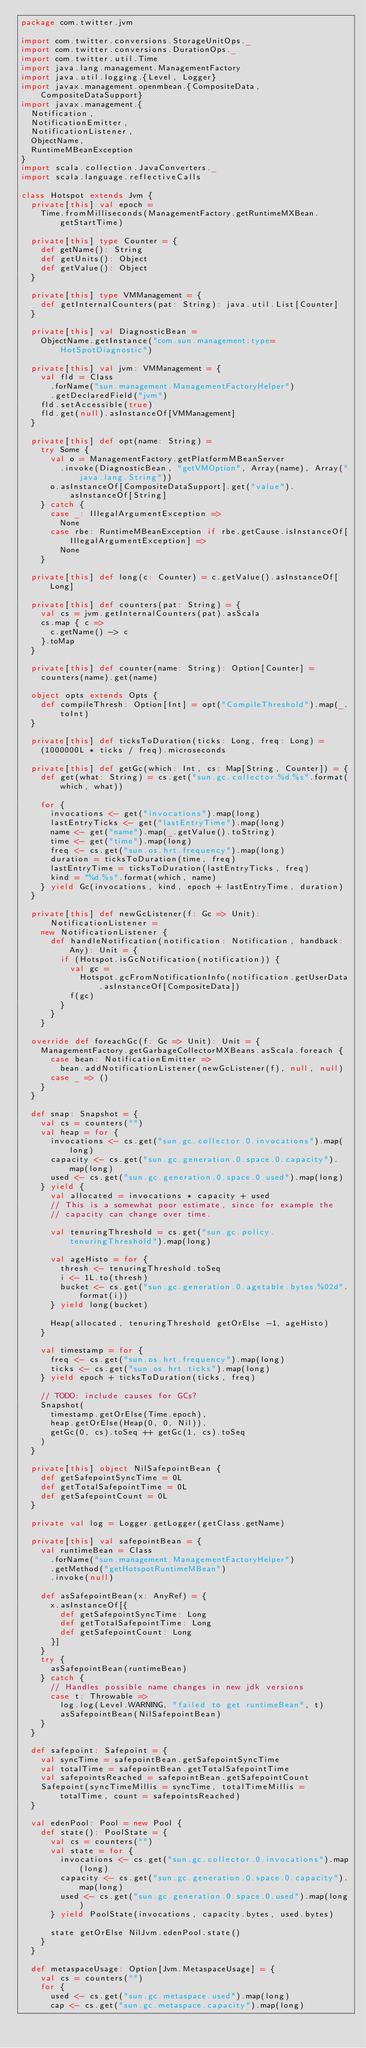<code> <loc_0><loc_0><loc_500><loc_500><_Scala_>package com.twitter.jvm

import com.twitter.conversions.StorageUnitOps._
import com.twitter.conversions.DurationOps._
import com.twitter.util.Time
import java.lang.management.ManagementFactory
import java.util.logging.{Level, Logger}
import javax.management.openmbean.{CompositeData, CompositeDataSupport}
import javax.management.{
  Notification,
  NotificationEmitter,
  NotificationListener,
  ObjectName,
  RuntimeMBeanException
}
import scala.collection.JavaConverters._
import scala.language.reflectiveCalls

class Hotspot extends Jvm {
  private[this] val epoch =
    Time.fromMilliseconds(ManagementFactory.getRuntimeMXBean.getStartTime)

  private[this] type Counter = {
    def getName(): String
    def getUnits(): Object
    def getValue(): Object
  }

  private[this] type VMManagement = {
    def getInternalCounters(pat: String): java.util.List[Counter]
  }

  private[this] val DiagnosticBean =
    ObjectName.getInstance("com.sun.management:type=HotSpotDiagnostic")

  private[this] val jvm: VMManagement = {
    val fld = Class
      .forName("sun.management.ManagementFactoryHelper")
      .getDeclaredField("jvm")
    fld.setAccessible(true)
    fld.get(null).asInstanceOf[VMManagement]
  }

  private[this] def opt(name: String) =
    try Some {
      val o = ManagementFactory.getPlatformMBeanServer
        .invoke(DiagnosticBean, "getVMOption", Array(name), Array("java.lang.String"))
      o.asInstanceOf[CompositeDataSupport].get("value").asInstanceOf[String]
    } catch {
      case _: IllegalArgumentException =>
        None
      case rbe: RuntimeMBeanException if rbe.getCause.isInstanceOf[IllegalArgumentException] =>
        None
    }

  private[this] def long(c: Counter) = c.getValue().asInstanceOf[Long]

  private[this] def counters(pat: String) = {
    val cs = jvm.getInternalCounters(pat).asScala
    cs.map { c =>
      c.getName() -> c
    }.toMap
  }

  private[this] def counter(name: String): Option[Counter] =
    counters(name).get(name)

  object opts extends Opts {
    def compileThresh: Option[Int] = opt("CompileThreshold").map(_.toInt)
  }

  private[this] def ticksToDuration(ticks: Long, freq: Long) =
    (1000000L * ticks / freq).microseconds

  private[this] def getGc(which: Int, cs: Map[String, Counter]) = {
    def get(what: String) = cs.get("sun.gc.collector.%d.%s".format(which, what))

    for {
      invocations <- get("invocations").map(long)
      lastEntryTicks <- get("lastEntryTime").map(long)
      name <- get("name").map(_.getValue().toString)
      time <- get("time").map(long)
      freq <- cs.get("sun.os.hrt.frequency").map(long)
      duration = ticksToDuration(time, freq)
      lastEntryTime = ticksToDuration(lastEntryTicks, freq)
      kind = "%d.%s".format(which, name)
    } yield Gc(invocations, kind, epoch + lastEntryTime, duration)
  }

  private[this] def newGcListener(f: Gc => Unit): NotificationListener =
    new NotificationListener {
      def handleNotification(notification: Notification, handback: Any): Unit = {
        if (Hotspot.isGcNotification(notification)) {
          val gc =
            Hotspot.gcFromNotificationInfo(notification.getUserData.asInstanceOf[CompositeData])
          f(gc)
        }
      }
    }

  override def foreachGc(f: Gc => Unit): Unit = {
    ManagementFactory.getGarbageCollectorMXBeans.asScala.foreach {
      case bean: NotificationEmitter =>
        bean.addNotificationListener(newGcListener(f), null, null)
      case _ => ()
    }
  }

  def snap: Snapshot = {
    val cs = counters("")
    val heap = for {
      invocations <- cs.get("sun.gc.collector.0.invocations").map(long)
      capacity <- cs.get("sun.gc.generation.0.space.0.capacity").map(long)
      used <- cs.get("sun.gc.generation.0.space.0.used").map(long)
    } yield {
      val allocated = invocations * capacity + used
      // This is a somewhat poor estimate, since for example the
      // capacity can change over time.

      val tenuringThreshold = cs.get("sun.gc.policy.tenuringThreshold").map(long)

      val ageHisto = for {
        thresh <- tenuringThreshold.toSeq
        i <- 1L.to(thresh)
        bucket <- cs.get("sun.gc.generation.0.agetable.bytes.%02d".format(i))
      } yield long(bucket)

      Heap(allocated, tenuringThreshold getOrElse -1, ageHisto)
    }

    val timestamp = for {
      freq <- cs.get("sun.os.hrt.frequency").map(long)
      ticks <- cs.get("sun.os.hrt.ticks").map(long)
    } yield epoch + ticksToDuration(ticks, freq)

    // TODO: include causes for GCs?
    Snapshot(
      timestamp.getOrElse(Time.epoch),
      heap.getOrElse(Heap(0, 0, Nil)),
      getGc(0, cs).toSeq ++ getGc(1, cs).toSeq
    )
  }

  private[this] object NilSafepointBean {
    def getSafepointSyncTime = 0L
    def getTotalSafepointTime = 0L
    def getSafepointCount = 0L
  }

  private val log = Logger.getLogger(getClass.getName)

  private[this] val safepointBean = {
    val runtimeBean = Class
      .forName("sun.management.ManagementFactoryHelper")
      .getMethod("getHotspotRuntimeMBean")
      .invoke(null)

    def asSafepointBean(x: AnyRef) = {
      x.asInstanceOf[{
        def getSafepointSyncTime: Long
        def getTotalSafepointTime: Long
        def getSafepointCount: Long
      }]
    }
    try {
      asSafepointBean(runtimeBean)
    } catch {
      // Handles possible name changes in new jdk versions
      case t: Throwable =>
        log.log(Level.WARNING, "failed to get runtimeBean", t)
        asSafepointBean(NilSafepointBean)
    }
  }

  def safepoint: Safepoint = {
    val syncTime = safepointBean.getSafepointSyncTime
    val totalTime = safepointBean.getTotalSafepointTime
    val safepointsReached = safepointBean.getSafepointCount
    Safepoint(syncTimeMillis = syncTime, totalTimeMillis = totalTime, count = safepointsReached)
  }

  val edenPool: Pool = new Pool {
    def state(): PoolState = {
      val cs = counters("")
      val state = for {
        invocations <- cs.get("sun.gc.collector.0.invocations").map(long)
        capacity <- cs.get("sun.gc.generation.0.space.0.capacity").map(long)
        used <- cs.get("sun.gc.generation.0.space.0.used").map(long)
      } yield PoolState(invocations, capacity.bytes, used.bytes)

      state getOrElse NilJvm.edenPool.state()
    }
  }

  def metaspaceUsage: Option[Jvm.MetaspaceUsage] = {
    val cs = counters("")
    for {
      used <- cs.get("sun.gc.metaspace.used").map(long)
      cap <- cs.get("sun.gc.metaspace.capacity").map(long)</code> 